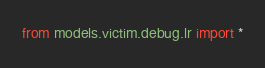Convert code to text. <code><loc_0><loc_0><loc_500><loc_500><_Python_>from models.victim.debug.lr import *
</code> 